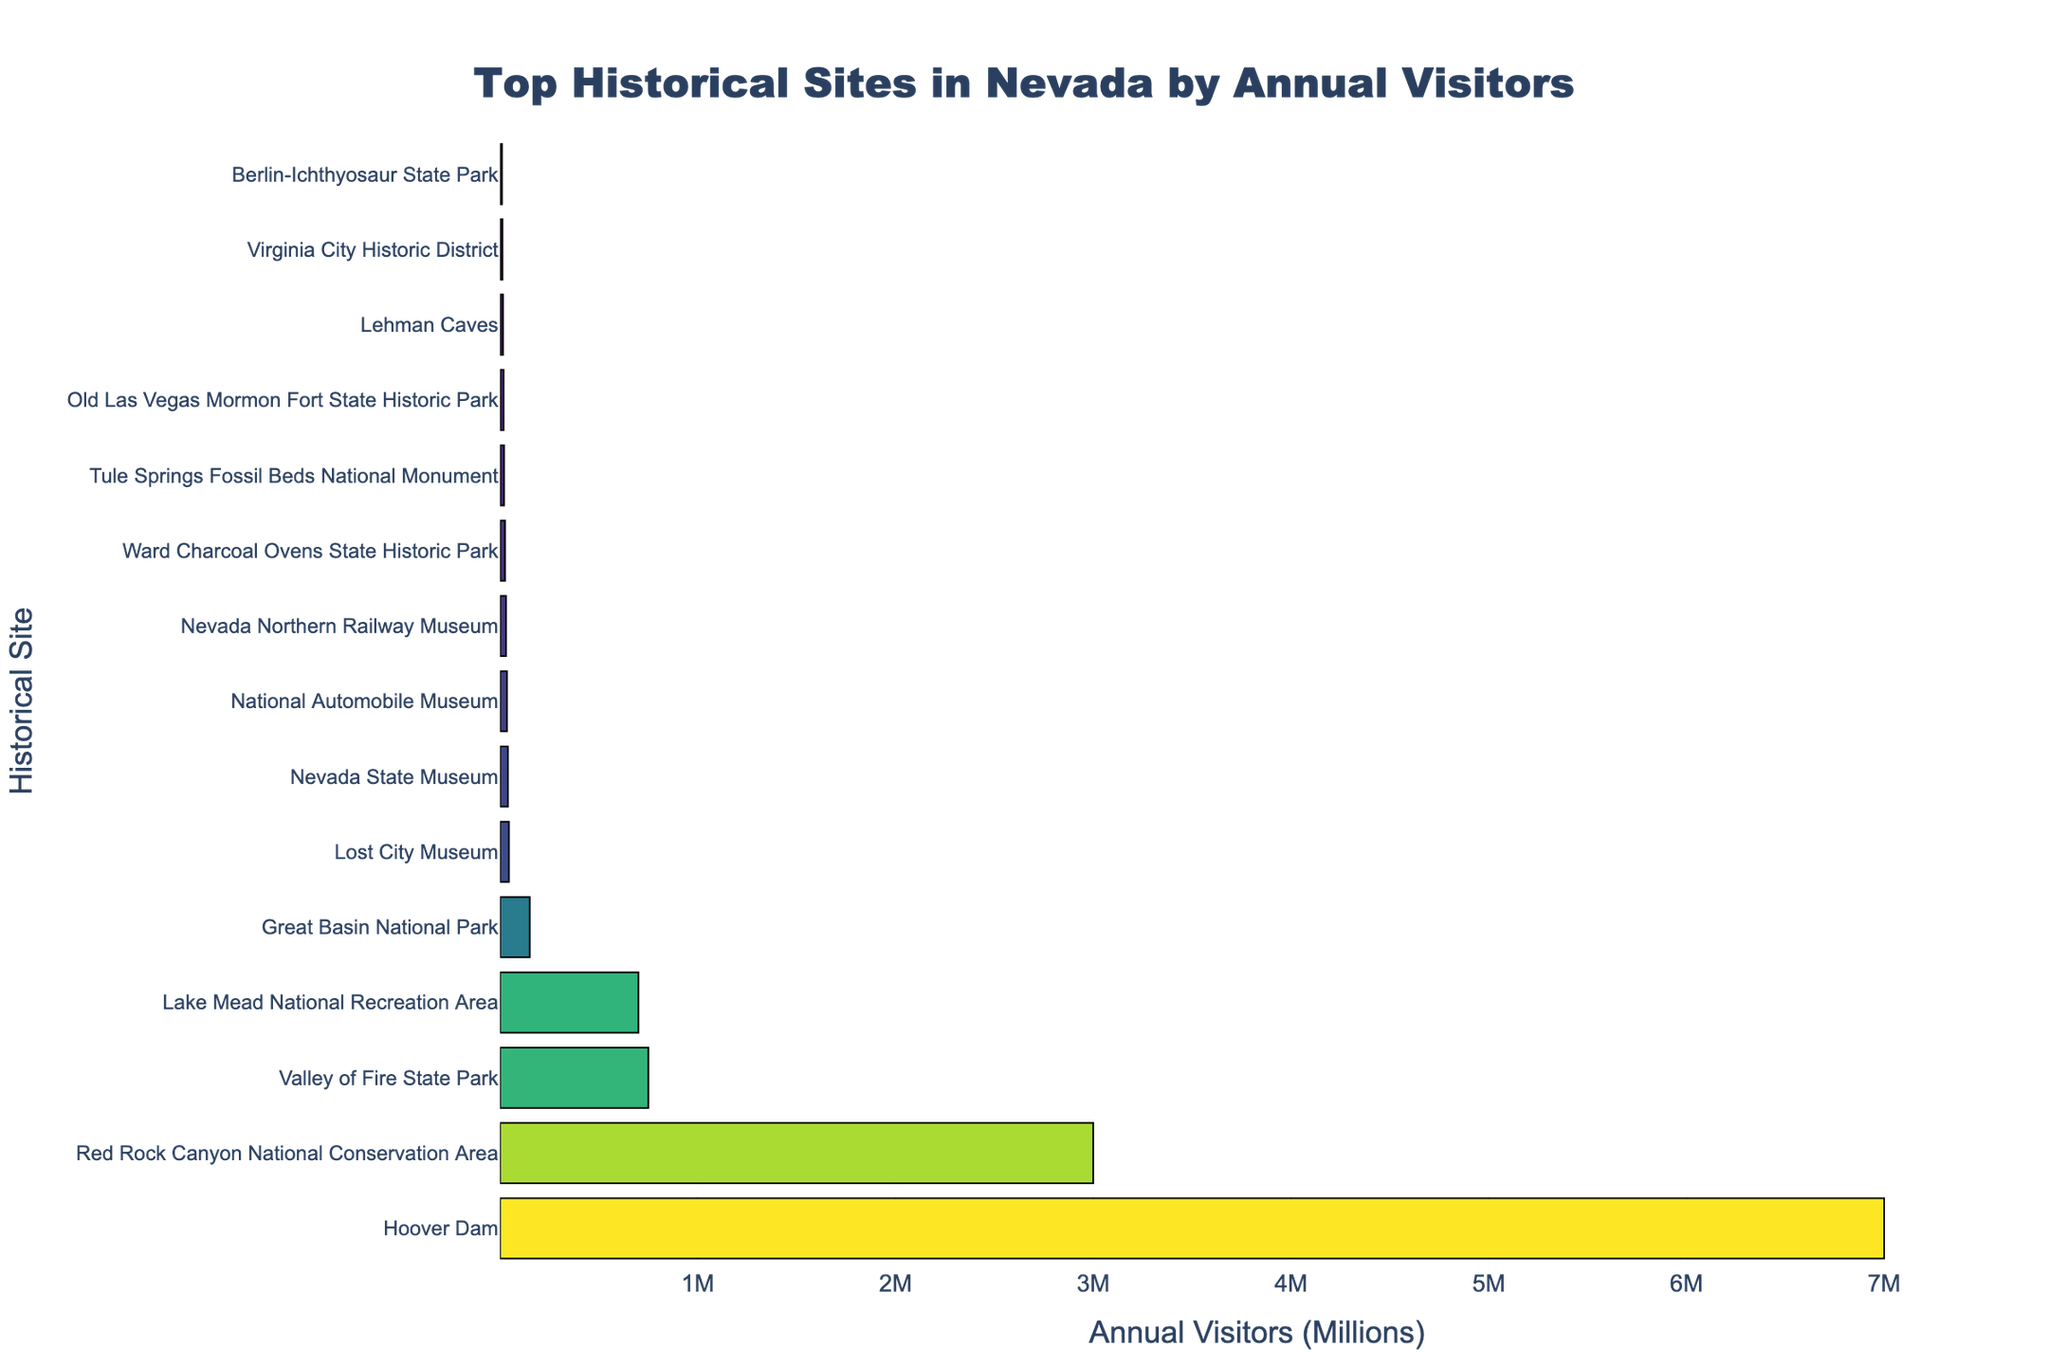Which historical site has the highest annual visitor count? By looking at the highest bar on the chart, Hoover Dam has the highest annual visitor count.
Answer: Hoover Dam What is the difference in annual visitors between the Hoover Dam and the Red Rock Canyon National Conservation Area? The visitor count for Hoover Dam is 7,000,000 and for Red Rock Canyon is 3,000,000. The difference is 7,000,000 - 3,000,000 = 4,000,000.
Answer: 4,000,000 Which site has fewer visitors: Ward Charcoal Ovens State Historic Park or Lehman Caves? By comparing the lengths of the bars for Ward Charcoal Ovens State Historic Park and Lehman Caves, Lehman Caves has fewer visitors.
Answer: Lehman Caves What is the total number of annual visitors for Nevada State Museum, National Automobile Museum, and Nevada Northern Railway Museum combined? The visitor counts are: Nevada State Museum (40,000), National Automobile Museum (35,000), Nevada Northern Railway Museum (30,000). The total is 40,000 + 35,000 + 30,000 = 105,000.
Answer: 105,000 How many more visitors does the Valley of Fire State Park get compared to Lake Mead National Recreation Area? Valley of Fire State Park has 750,000 visitors and Lake Mead National Recreation Area has 700,000. The difference is 750,000 - 700,000 = 50,000.
Answer: 50,000 What site has the third highest number of annual visitors, and how many does it get? The third highest bar represents Valley of Fire State Park with 750,000 annual visitors.
Answer: Valley of Fire State Park, 750,000 Which site has a visitor count closer to 20,000: Old Las Vegas Mormon Fort State Historic Park or Tule Springs Fossil Beds National Monument? By comparing the bars, Tule Springs Fossil Beds National Monument has 20,000 visitors, whereas Old Las Vegas Mormon Fort State Historic Park has 18,000. Tule Springs Fossil Beds National Monument is closer to 20,000.
Answer: Tule Springs Fossil Beds National Monument What is the combined annual visitor count for the top 3 most visited historical sites? The top three sites are Hoover Dam (7,000,000), Red Rock Canyon National Conservation Area (3,000,000), and Valley of Fire State Park (750,000). The combined count is 7,000,000 + 3,000,000 + 750,000 = 10,750,000.
Answer: 10,750,000 Which has more visitors: the Great Basin National Park or the Lost City Museum? The bar for Great Basin National Park is longer, representing 150,000 visitors, compared to Lost City Museum with 45,000 visitors.
Answer: Great Basin National Park 